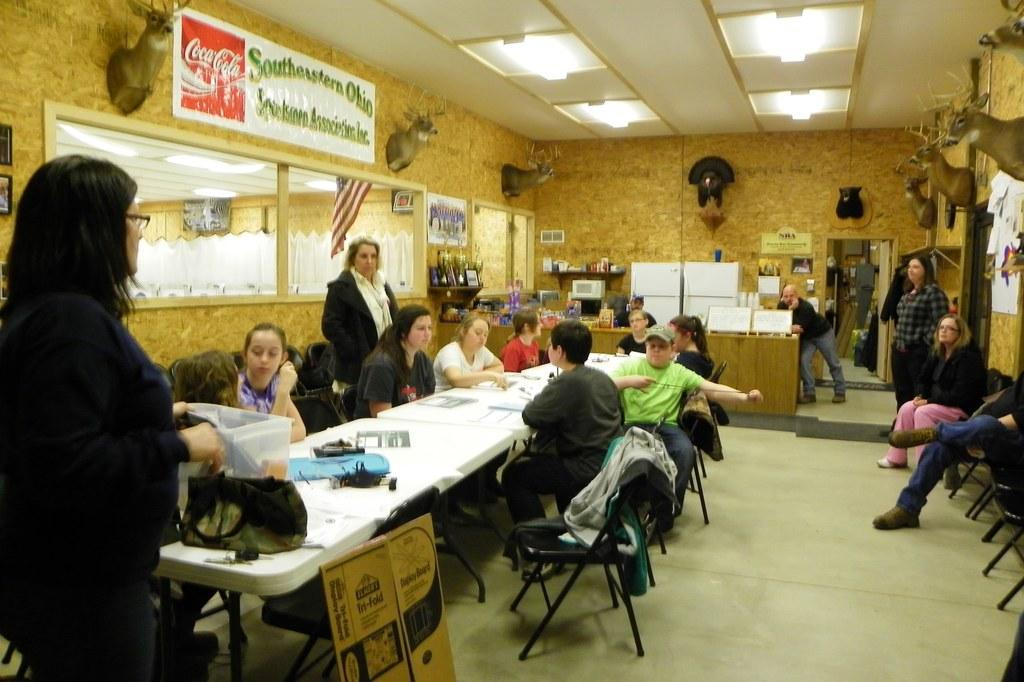What are the people in the image doing? There are people sitting on chairs and people standing in the image. Can you describe the positions of the people in the image? Some people are sitting on chairs, while others are standing. What type of twist can be seen in the image? There is no twist present in the image. How many cushions are visible in the image? There is no mention of cushions in the provided facts, so it cannot be determined from the image. 